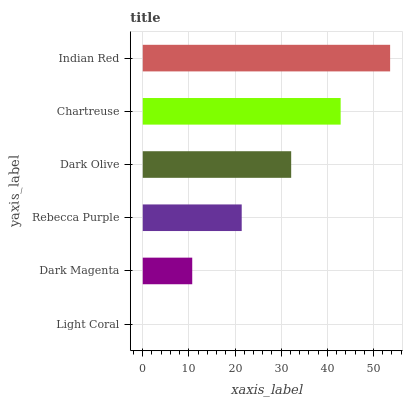Is Light Coral the minimum?
Answer yes or no. Yes. Is Indian Red the maximum?
Answer yes or no. Yes. Is Dark Magenta the minimum?
Answer yes or no. No. Is Dark Magenta the maximum?
Answer yes or no. No. Is Dark Magenta greater than Light Coral?
Answer yes or no. Yes. Is Light Coral less than Dark Magenta?
Answer yes or no. Yes. Is Light Coral greater than Dark Magenta?
Answer yes or no. No. Is Dark Magenta less than Light Coral?
Answer yes or no. No. Is Dark Olive the high median?
Answer yes or no. Yes. Is Rebecca Purple the low median?
Answer yes or no. Yes. Is Rebecca Purple the high median?
Answer yes or no. No. Is Indian Red the low median?
Answer yes or no. No. 